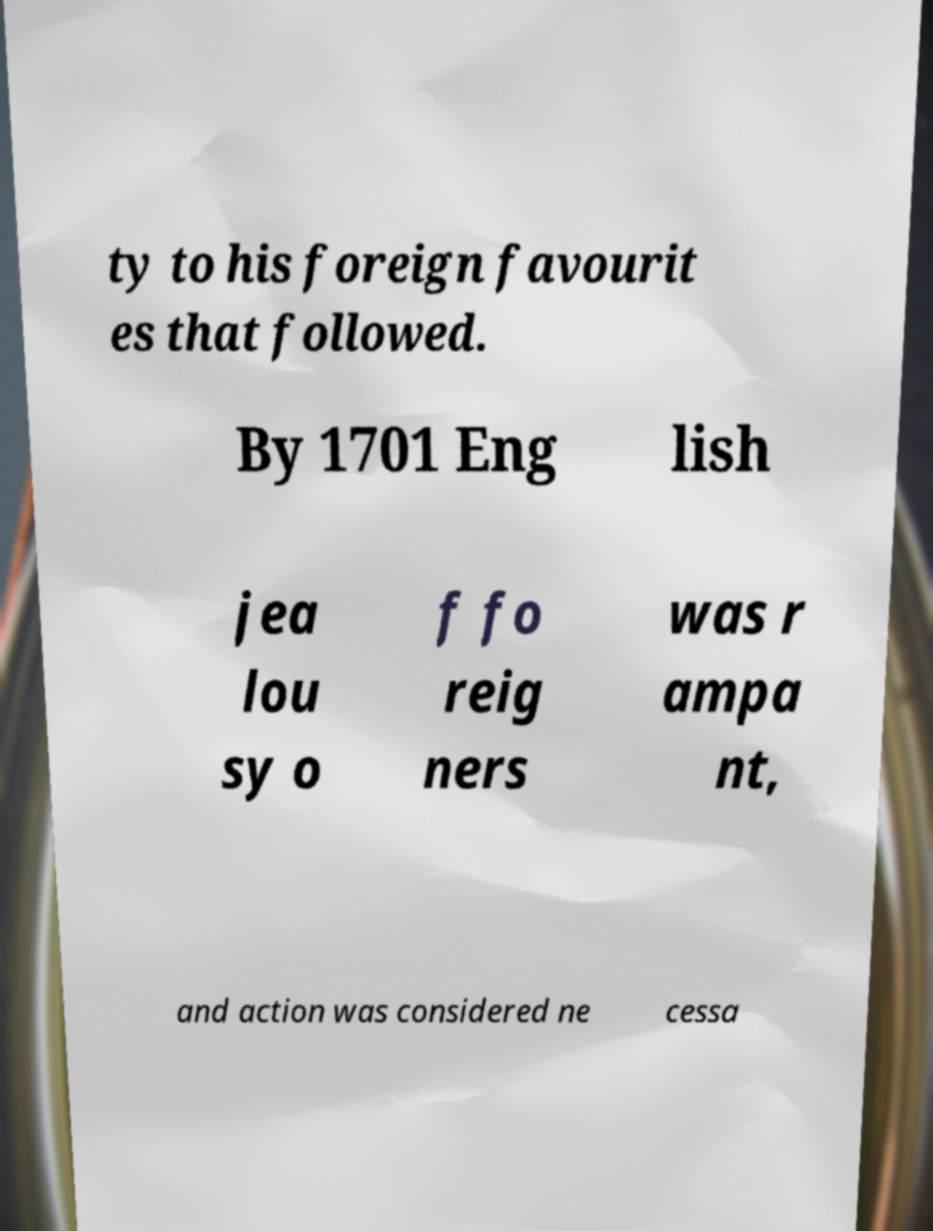Could you extract and type out the text from this image? ty to his foreign favourit es that followed. By 1701 Eng lish jea lou sy o f fo reig ners was r ampa nt, and action was considered ne cessa 